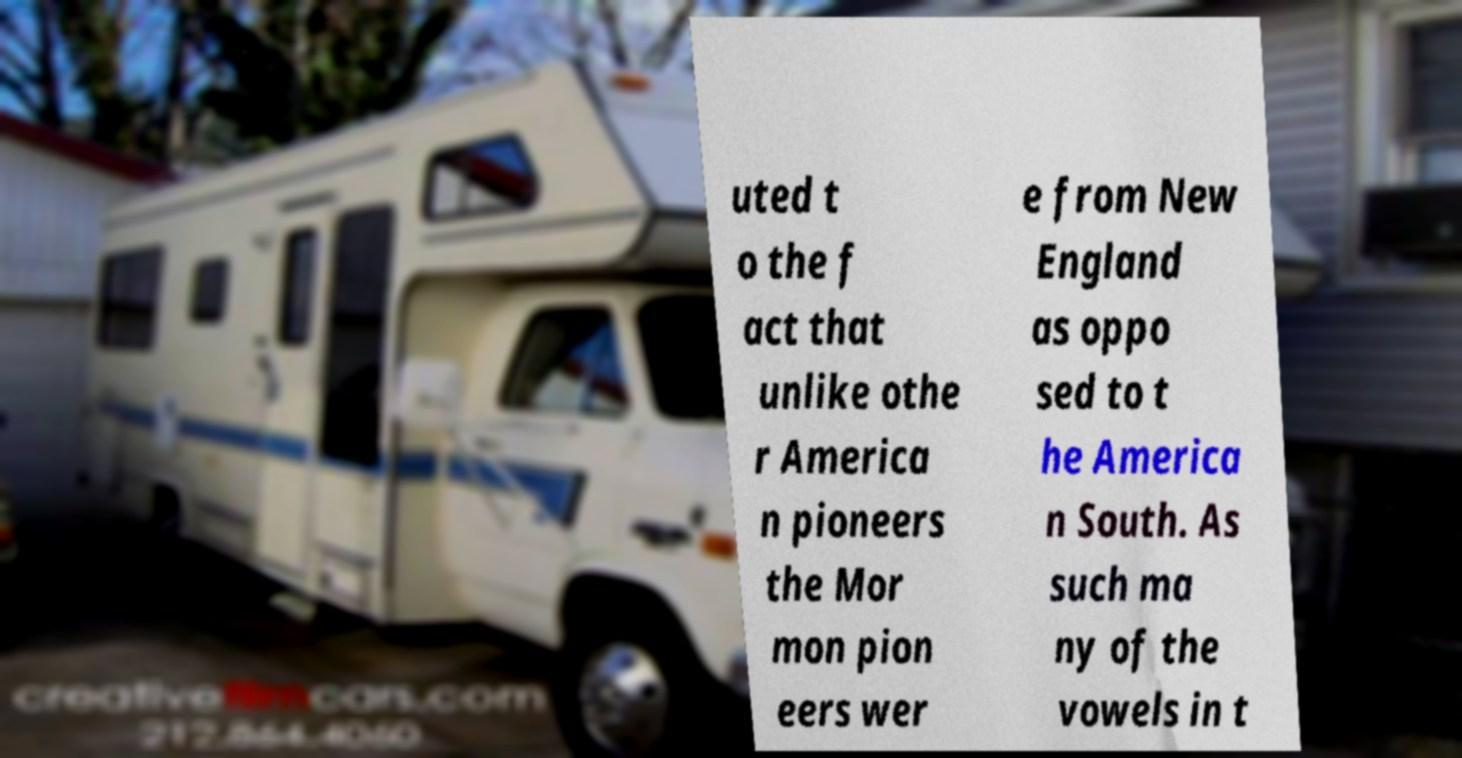Could you extract and type out the text from this image? uted t o the f act that unlike othe r America n pioneers the Mor mon pion eers wer e from New England as oppo sed to t he America n South. As such ma ny of the vowels in t 